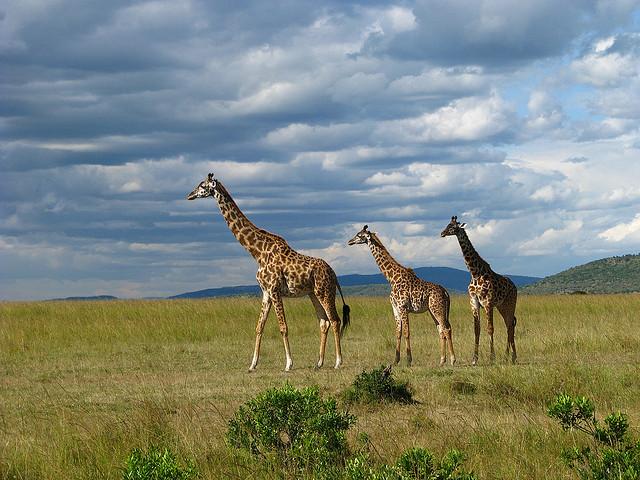Which direction are they headed?
Answer briefly. Left. Are there any trees in the picture?
Short answer required. No. Is it storming in the image?
Give a very brief answer. No. How giraffes are pictured?
Answer briefly. 3. 